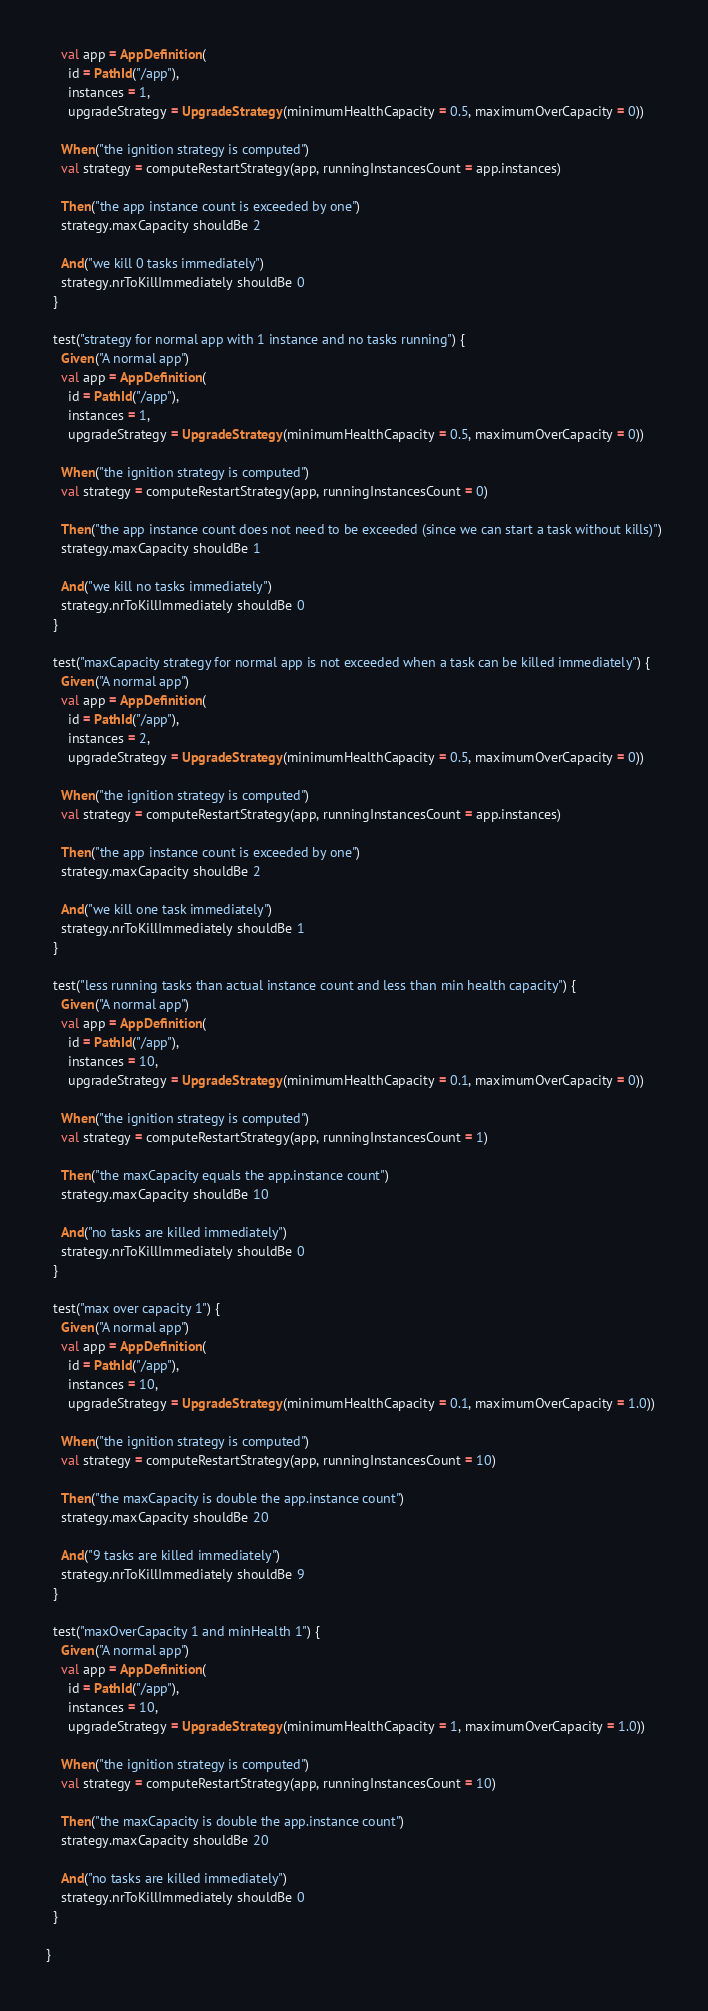<code> <loc_0><loc_0><loc_500><loc_500><_Scala_>    val app = AppDefinition(
      id = PathId("/app"),
      instances = 1,
      upgradeStrategy = UpgradeStrategy(minimumHealthCapacity = 0.5, maximumOverCapacity = 0))

    When("the ignition strategy is computed")
    val strategy = computeRestartStrategy(app, runningInstancesCount = app.instances)

    Then("the app instance count is exceeded by one")
    strategy.maxCapacity shouldBe 2

    And("we kill 0 tasks immediately")
    strategy.nrToKillImmediately shouldBe 0
  }

  test("strategy for normal app with 1 instance and no tasks running") {
    Given("A normal app")
    val app = AppDefinition(
      id = PathId("/app"),
      instances = 1,
      upgradeStrategy = UpgradeStrategy(minimumHealthCapacity = 0.5, maximumOverCapacity = 0))

    When("the ignition strategy is computed")
    val strategy = computeRestartStrategy(app, runningInstancesCount = 0)

    Then("the app instance count does not need to be exceeded (since we can start a task without kills)")
    strategy.maxCapacity shouldBe 1

    And("we kill no tasks immediately")
    strategy.nrToKillImmediately shouldBe 0
  }

  test("maxCapacity strategy for normal app is not exceeded when a task can be killed immediately") {
    Given("A normal app")
    val app = AppDefinition(
      id = PathId("/app"),
      instances = 2,
      upgradeStrategy = UpgradeStrategy(minimumHealthCapacity = 0.5, maximumOverCapacity = 0))

    When("the ignition strategy is computed")
    val strategy = computeRestartStrategy(app, runningInstancesCount = app.instances)

    Then("the app instance count is exceeded by one")
    strategy.maxCapacity shouldBe 2

    And("we kill one task immediately")
    strategy.nrToKillImmediately shouldBe 1
  }

  test("less running tasks than actual instance count and less than min health capacity") {
    Given("A normal app")
    val app = AppDefinition(
      id = PathId("/app"),
      instances = 10,
      upgradeStrategy = UpgradeStrategy(minimumHealthCapacity = 0.1, maximumOverCapacity = 0))

    When("the ignition strategy is computed")
    val strategy = computeRestartStrategy(app, runningInstancesCount = 1)

    Then("the maxCapacity equals the app.instance count")
    strategy.maxCapacity shouldBe 10

    And("no tasks are killed immediately")
    strategy.nrToKillImmediately shouldBe 0
  }

  test("max over capacity 1") {
    Given("A normal app")
    val app = AppDefinition(
      id = PathId("/app"),
      instances = 10,
      upgradeStrategy = UpgradeStrategy(minimumHealthCapacity = 0.1, maximumOverCapacity = 1.0))

    When("the ignition strategy is computed")
    val strategy = computeRestartStrategy(app, runningInstancesCount = 10)

    Then("the maxCapacity is double the app.instance count")
    strategy.maxCapacity shouldBe 20

    And("9 tasks are killed immediately")
    strategy.nrToKillImmediately shouldBe 9
  }

  test("maxOverCapacity 1 and minHealth 1") {
    Given("A normal app")
    val app = AppDefinition(
      id = PathId("/app"),
      instances = 10,
      upgradeStrategy = UpgradeStrategy(minimumHealthCapacity = 1, maximumOverCapacity = 1.0))

    When("the ignition strategy is computed")
    val strategy = computeRestartStrategy(app, runningInstancesCount = 10)

    Then("the maxCapacity is double the app.instance count")
    strategy.maxCapacity shouldBe 20

    And("no tasks are killed immediately")
    strategy.nrToKillImmediately shouldBe 0
  }

}
</code> 